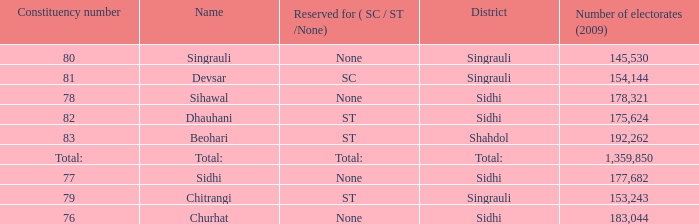What is Beohari's reserved for (SC/ST/None)? ST. 